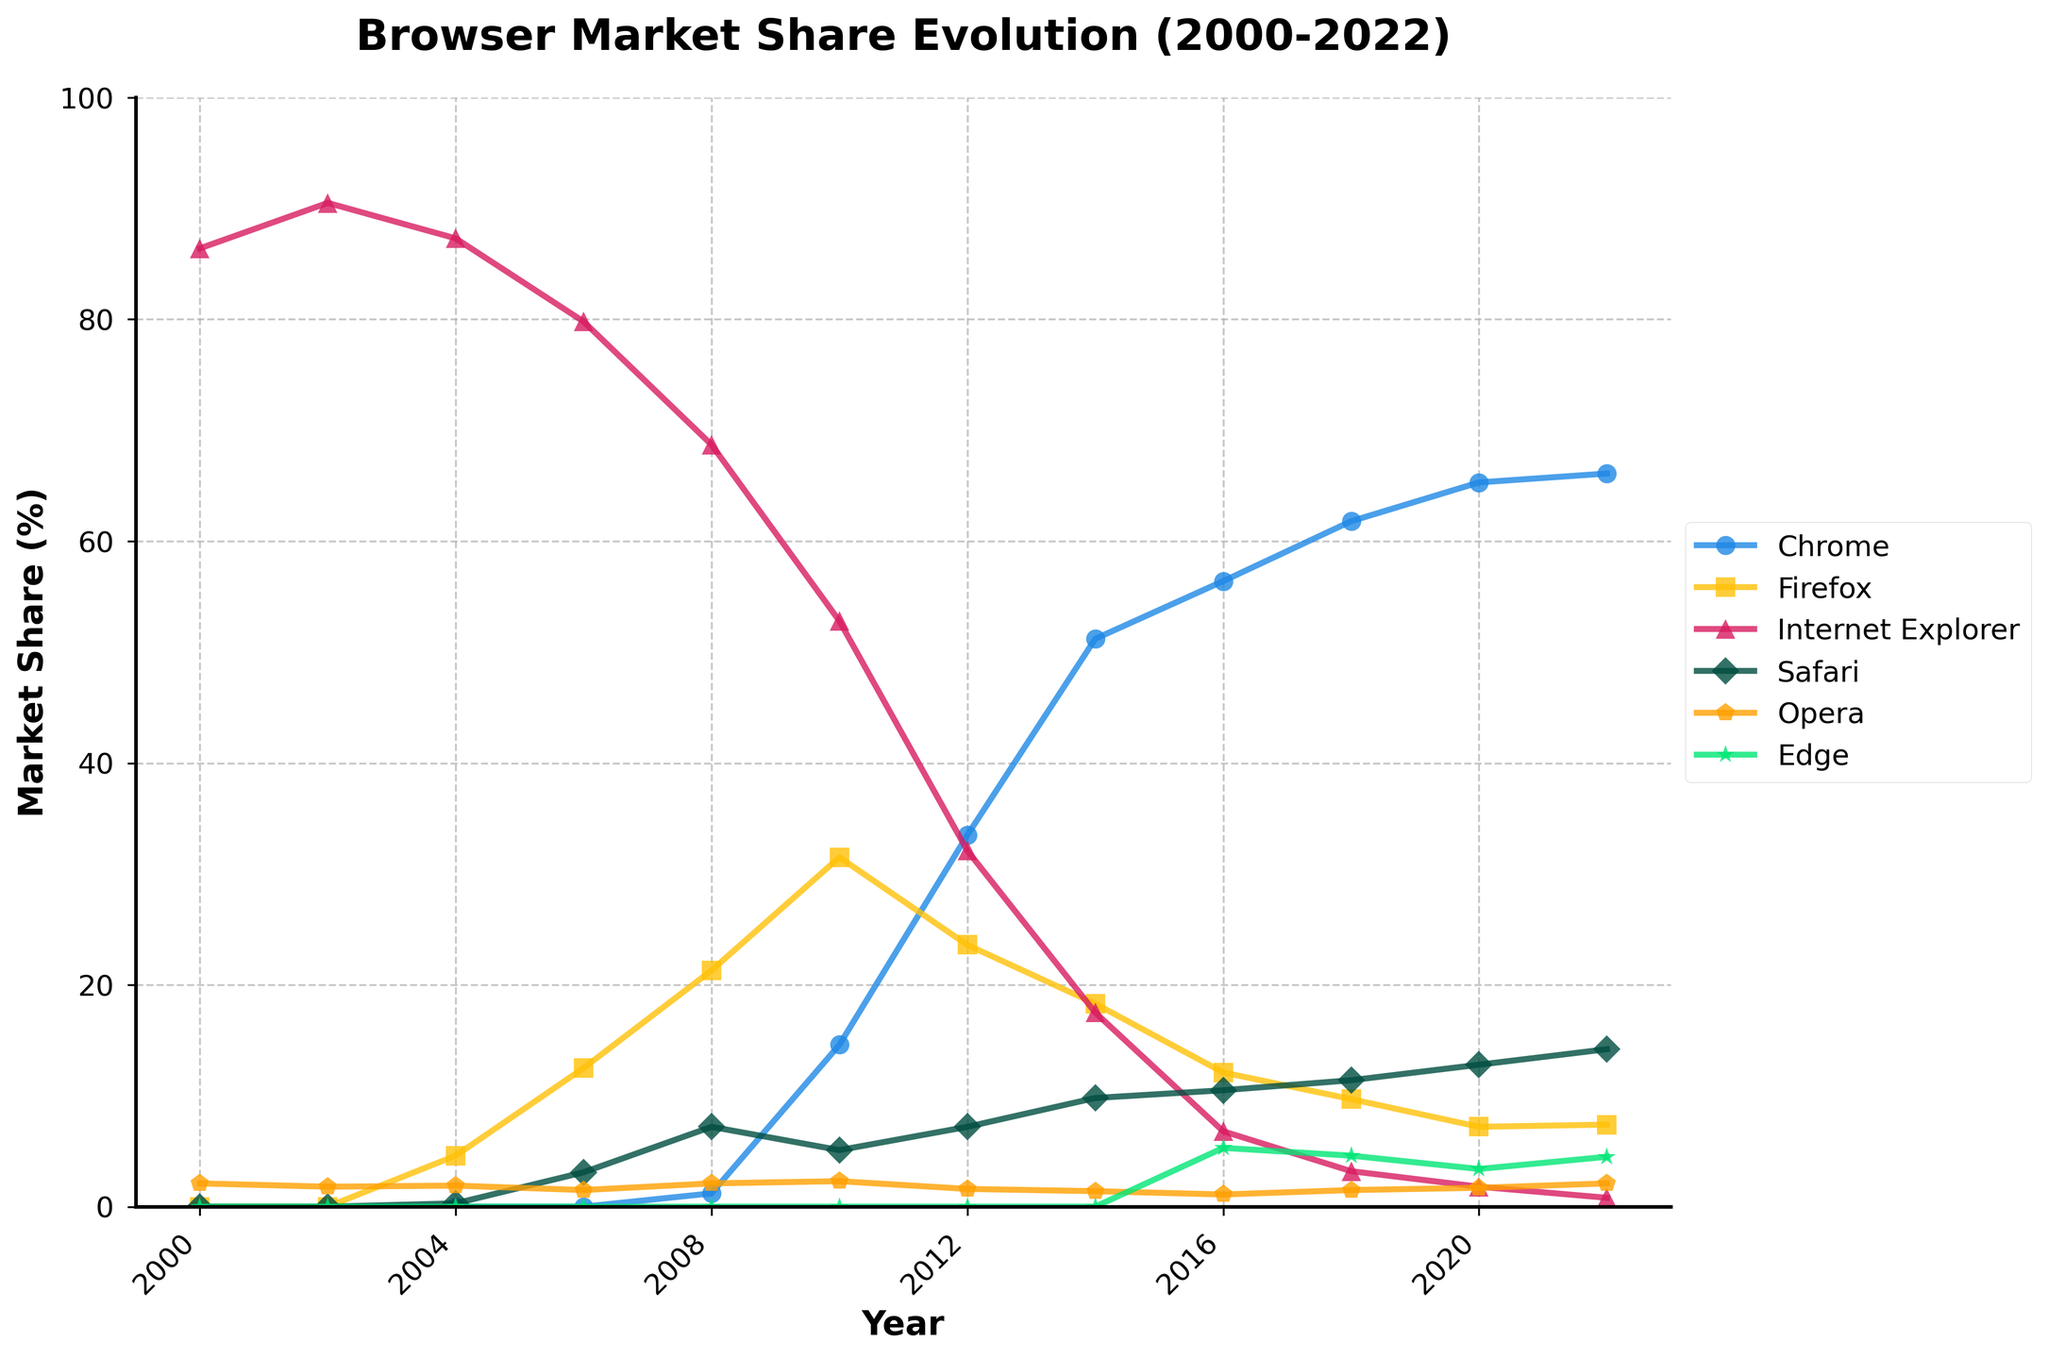Which browser had the highest market share in 2000? Look at the data points for different browsers in the year 2000. The highest value is for 'Internet Explorer' at 86.4%.
Answer: Internet Explorer Which year did Chrome first surpass Firefox in market share? Compare the market share lines for Chrome and Firefox. Chrome surpasses Firefox between 2010 and 2012.
Answer: 2012 What is the difference in market share between Chrome and Firefox in 2018? From the chart, locate the market share percentages for Chrome and Firefox in 2018. Subtract the Firefox value (9.7%) from the Chrome value (61.8%).
Answer: 52.1% Which browser experienced the most consistent decline in market share from 2000 to 2022? Observe the trend lines for each browser from 2000 to 2022. The trend line for 'Internet Explorer' shows a consistent decline.
Answer: Internet Explorer In 2020, how many browsers had a market share greater than 10%? Look at the market share percentages for all browsers in 2020 and count the number of browsers with values greater than 10%. Chrome (65.3%) and Safari (12.8%) meet this criterion.
Answer: 2 Which browser showed a significant increase in market share between 2006 and 2010? Compare the market share lines and values for each browser between 2006 and 2010. 'Chrome' shows a significant increase from 0% in 2006 to 14.6% in 2010.
Answer: Chrome Which browser had almost no significant change in its market share from 2016 to 2022? Observe the lines from 2016 to 2022. 'Opera' shows little change, remaining close to 1.1%–2.1%.
Answer: Opera What was the combined market share of Safari and Edge in 2018? Sum the market share percentages of Safari (11.4%) and Edge (4.6%) for 2018.
Answer: 16% In which year did three or more browsers have a market share of less than 5%? Identify the years where at least three browsers have market shares less than 5%. In 2020, Firefox (7.2%), Internet Explorer (1.8%), Opera (1.7%), and Edge (3.4%) are the browsers.
Answer: 2020 Which browser had the smallest market share in 2004? Compare the values for different browsers in 2004. 'Safari' has the smallest market share at 0.3%.
Answer: Safari 